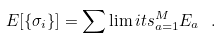<formula> <loc_0><loc_0><loc_500><loc_500>E [ \{ \sigma _ { i } \} ] = \sum \lim i t s _ { a = 1 } ^ { M } E _ { a } \ .</formula> 